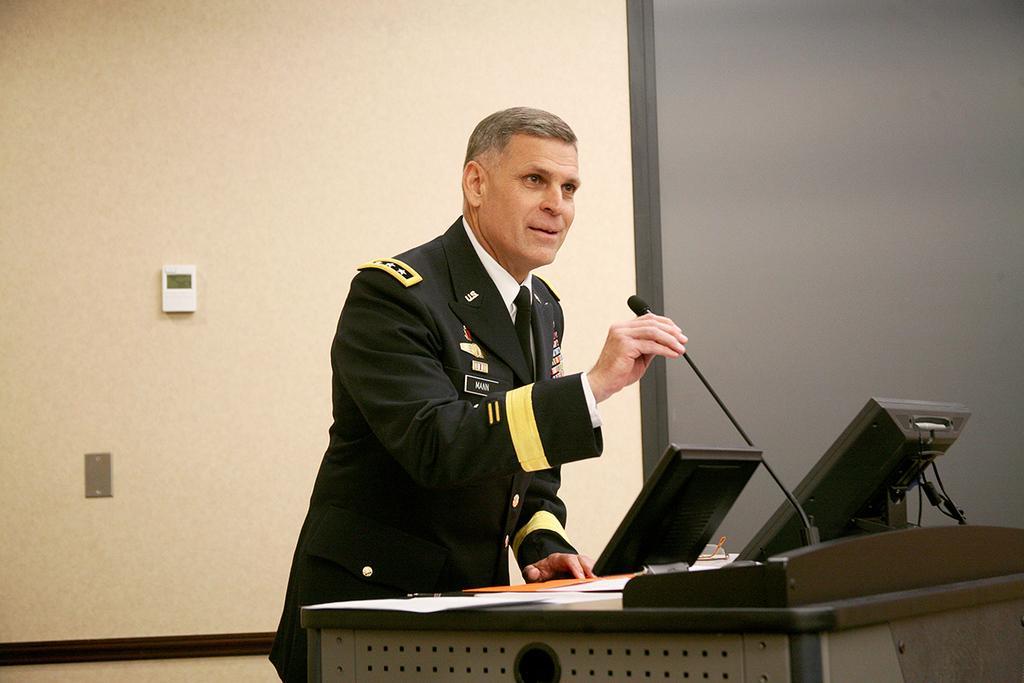How would you summarize this image in a sentence or two? In this image there is a person standing, he is holding a microphone, there is an object truncated towards the bottom of the image, there are papers, there are spectacles, there are monitors, there are wires, there is a wall truncated towards the right of the image, there is a wall truncated towards the left of the image, there is a wall truncated towards the top of the image, there is an object on the wall. 